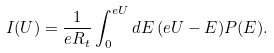<formula> <loc_0><loc_0><loc_500><loc_500>I ( U ) = \frac { 1 } { e R _ { t } } \int _ { 0 } ^ { e U } d E \, ( e U - E ) P ( E ) .</formula> 